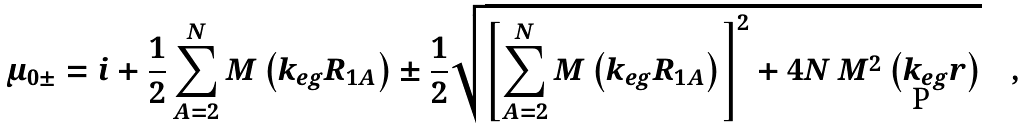Convert formula to latex. <formula><loc_0><loc_0><loc_500><loc_500>\mu _ { 0 \pm } = i + \frac { 1 } { 2 } \sum _ { A = 2 } ^ { N } M \left ( k _ { e g } R _ { 1 A } \right ) \pm \frac { 1 } { 2 } \sqrt { \left [ \sum _ { A = 2 } ^ { N } M \left ( k _ { e g } R _ { 1 A } \right ) \right ] ^ { 2 } + 4 N \, M ^ { 2 } \left ( k _ { e g } r \right ) } \quad ,</formula> 